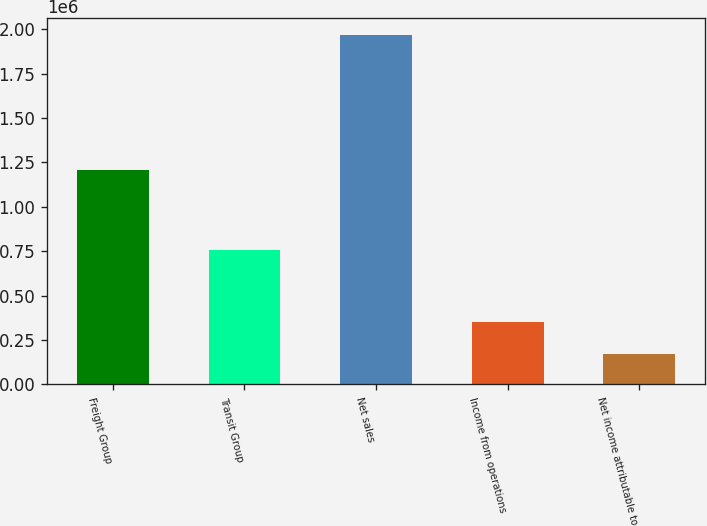Convert chart to OTSL. <chart><loc_0><loc_0><loc_500><loc_500><bar_chart><fcel>Freight Group<fcel>Transit Group<fcel>Net sales<fcel>Income from operations<fcel>Net income attributable to<nl><fcel>1.21006e+06<fcel>757578<fcel>1.96764e+06<fcel>350296<fcel>170591<nl></chart> 